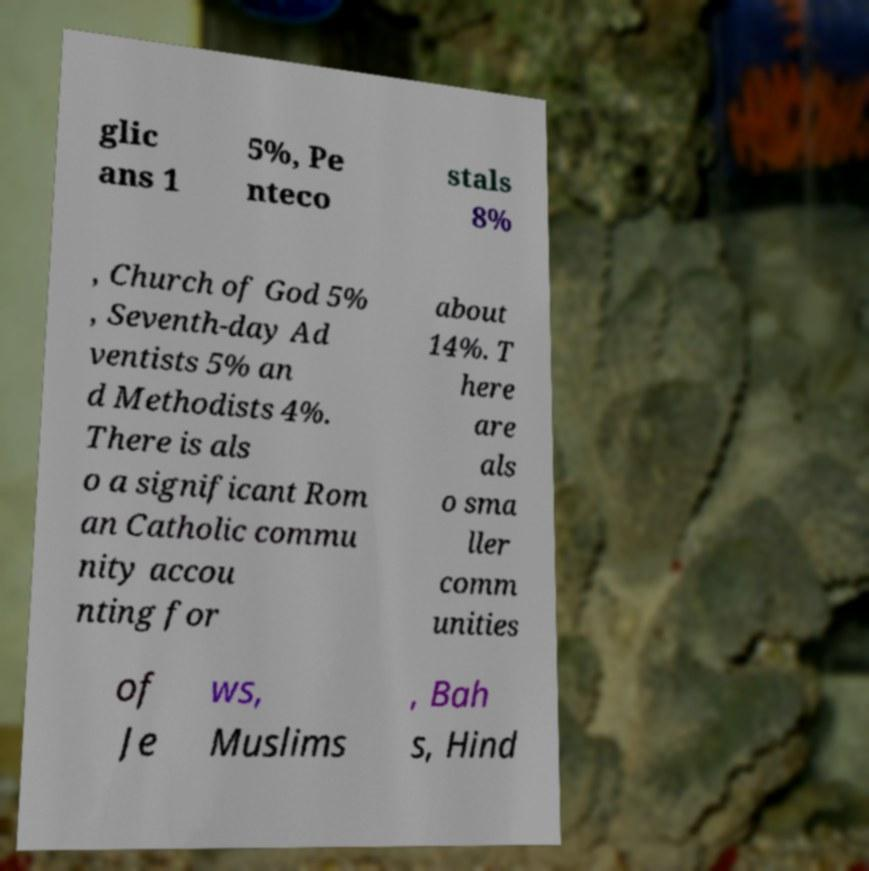There's text embedded in this image that I need extracted. Can you transcribe it verbatim? glic ans 1 5%, Pe nteco stals 8% , Church of God 5% , Seventh-day Ad ventists 5% an d Methodists 4%. There is als o a significant Rom an Catholic commu nity accou nting for about 14%. T here are als o sma ller comm unities of Je ws, Muslims , Bah s, Hind 